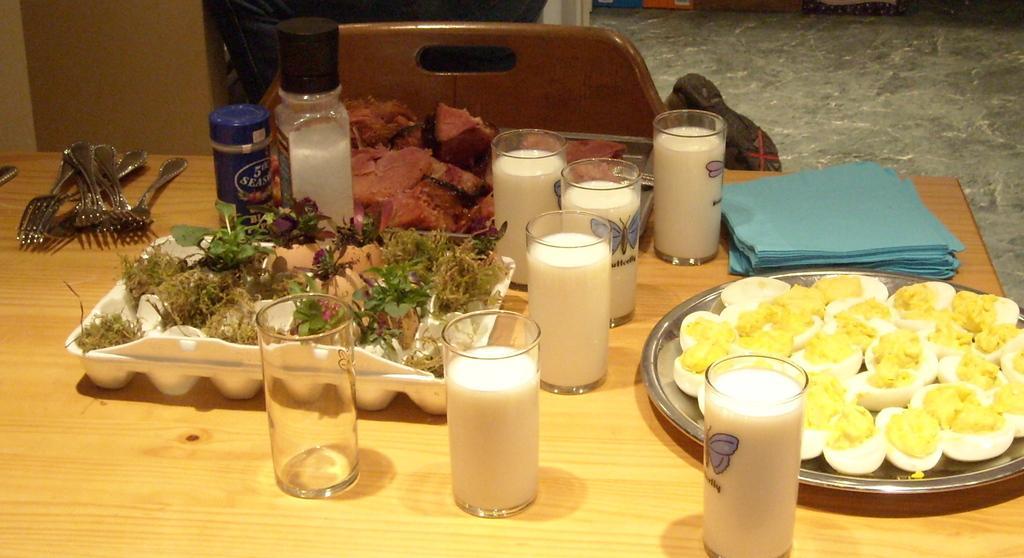How would you summarize this image in a sentence or two? In the picture we can see a table on it, we can see a plate with egg slices and beside it, we can see some glasses of milk and besides, we can see a tray with some leafy vegetables and beside it, we can some forks, and we can also see some blue color tissues and behind the table we can see a chair and beside it we can see a bag on the floor. 